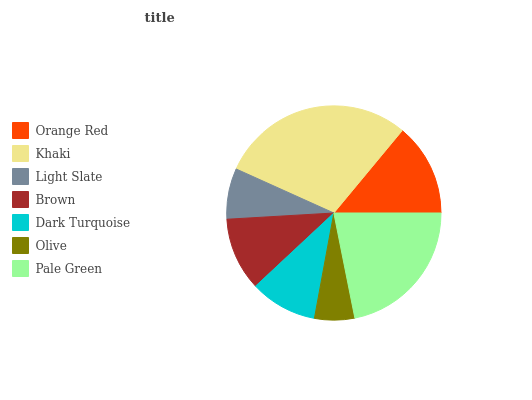Is Olive the minimum?
Answer yes or no. Yes. Is Khaki the maximum?
Answer yes or no. Yes. Is Light Slate the minimum?
Answer yes or no. No. Is Light Slate the maximum?
Answer yes or no. No. Is Khaki greater than Light Slate?
Answer yes or no. Yes. Is Light Slate less than Khaki?
Answer yes or no. Yes. Is Light Slate greater than Khaki?
Answer yes or no. No. Is Khaki less than Light Slate?
Answer yes or no. No. Is Brown the high median?
Answer yes or no. Yes. Is Brown the low median?
Answer yes or no. Yes. Is Khaki the high median?
Answer yes or no. No. Is Orange Red the low median?
Answer yes or no. No. 